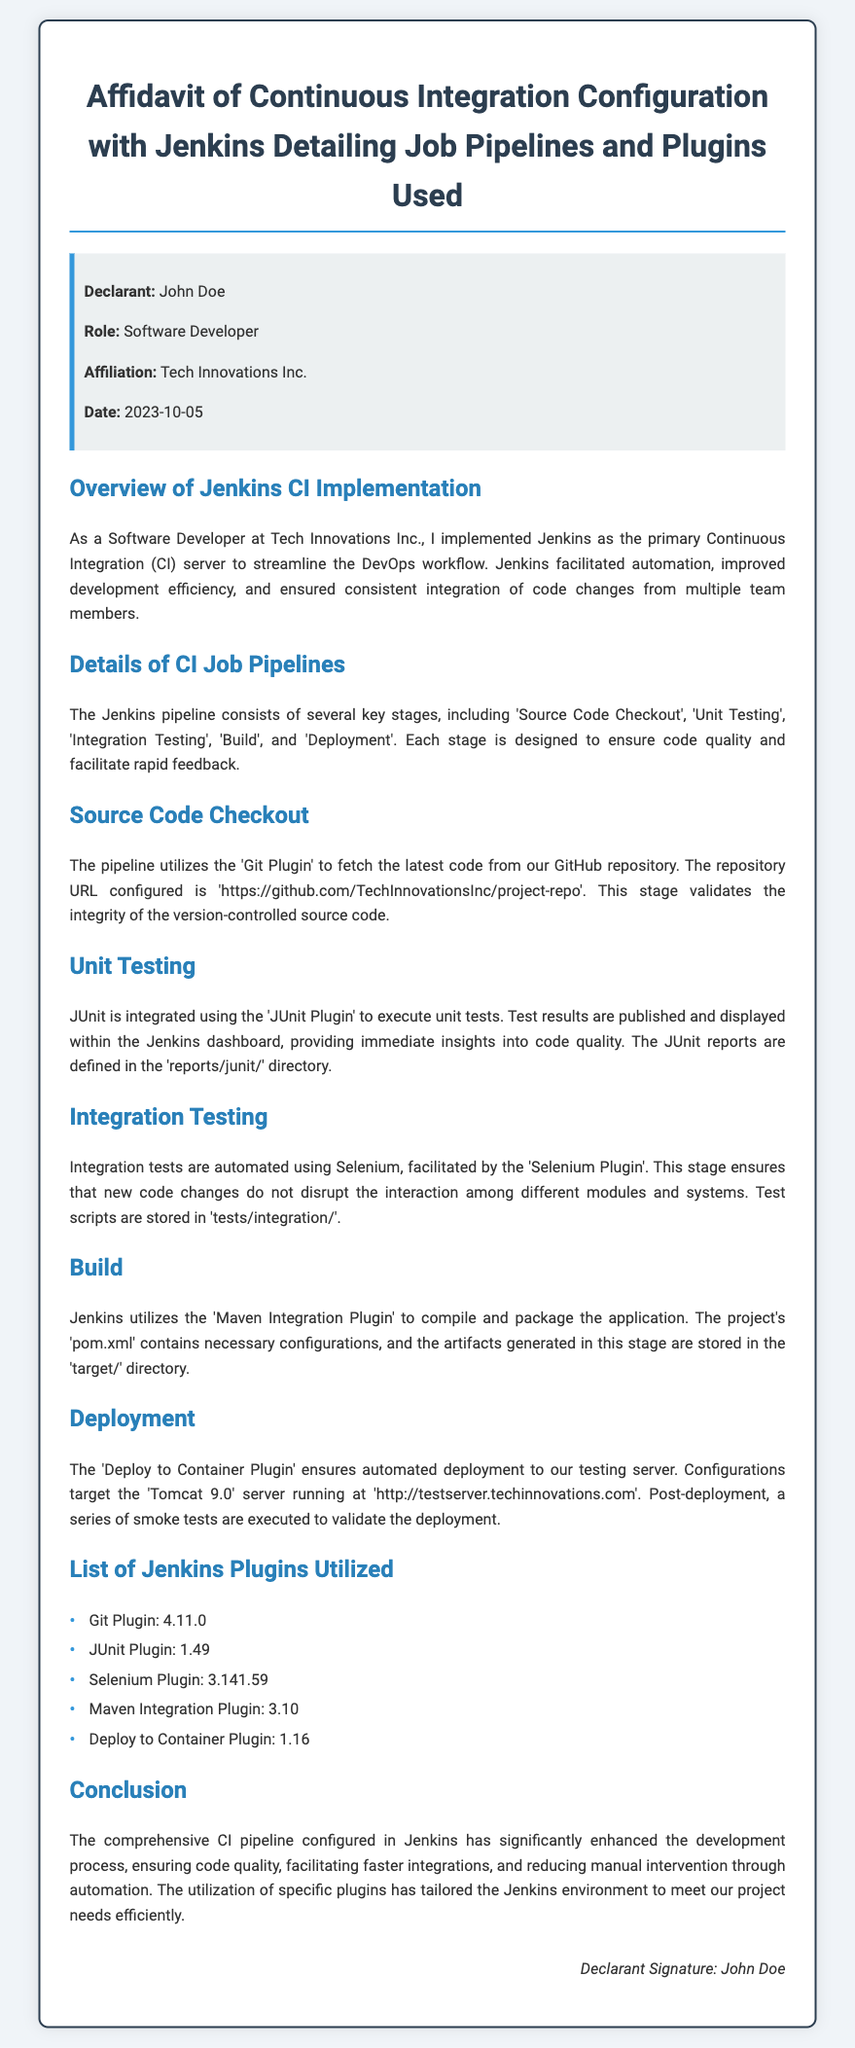What is the name of the declarant? The name of the declarant is stated in the document and is John Doe.
Answer: John Doe What role does the declarant hold? The document specifies the role of the declarant, which is Software Developer.
Answer: Software Developer When was the affidavit signed? The date is mentioned in the document as 2023-10-05.
Answer: 2023-10-05 What is the URL of the repository used for source code checkout? The document contains the repository URL, which is 'https://github.com/TechInnovationsInc/project-repo'.
Answer: https://github.com/TechInnovationsInc/project-repo Which plugin is used for unit testing? The document mentions the plugin used for unit testing, which is the JUnit Plugin.
Answer: JUnit Plugin How many main stages are there in the Jenkins pipeline? The document describes several stages, which totals to five key stages in the Jenkins pipeline.
Answer: Five What type of tests are automated using Selenium? The document indicates that integration tests are automated using Selenium.
Answer: Integration Testing Which server is targeted for deployment? The targeted server for deployment is mentioned as Tomcat 9.0.
Answer: Tomcat 9.0 What is the version of the Git Plugin used? The document provides the version of the Git Plugin, which is 4.11.0.
Answer: 4.11.0 What is the main benefit of the CI pipeline configured in Jenkins? The document concludes that the CI pipeline significantly enhances the development process.
Answer: Enhances development process 